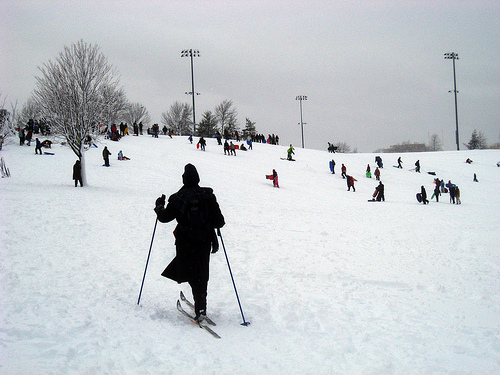Please provide the bounding box coordinate of the region this sentence describes: Bare snow covered tree growing on top of hill. [0.07, 0.2, 0.26, 0.52] precisely encapsulates the region with the bare, snow-covered tree atop the hill. 